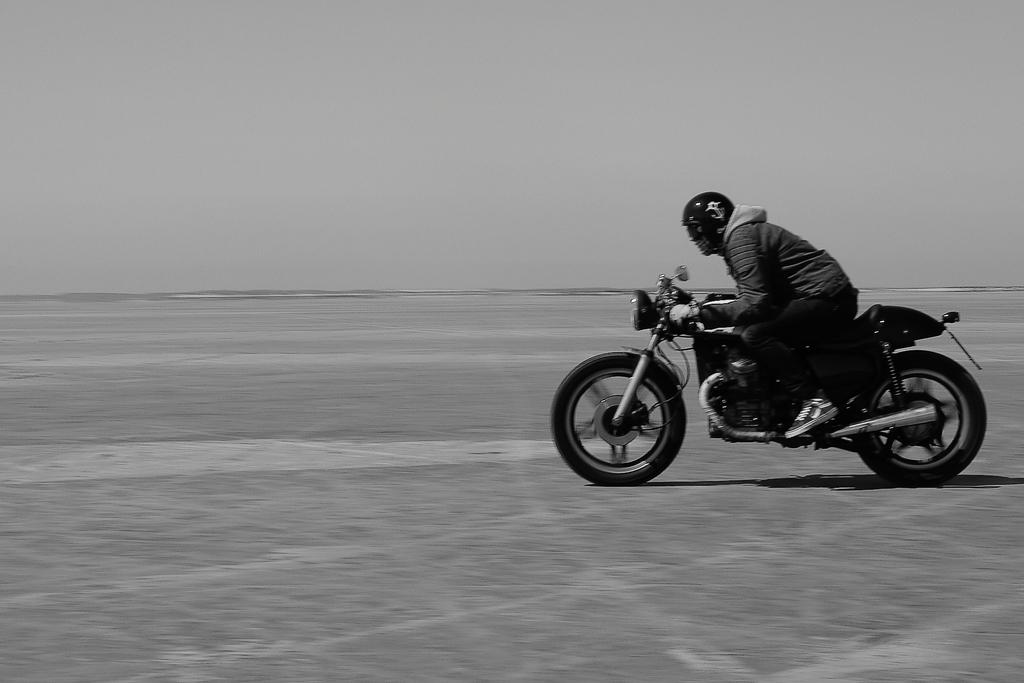Who is the main subject in the image? There is a man in the image. What is the man doing in the image? The man is riding a bike in the image. Where is the bike located? The bike is on a road in the image. What can be seen in the background of the image? There is a sky visible in the background of the image. What does the writer do to increase the number of words in the image? There is no writer or words present in the image; it features a man riding a bike on a road with a visible sky in the background. 